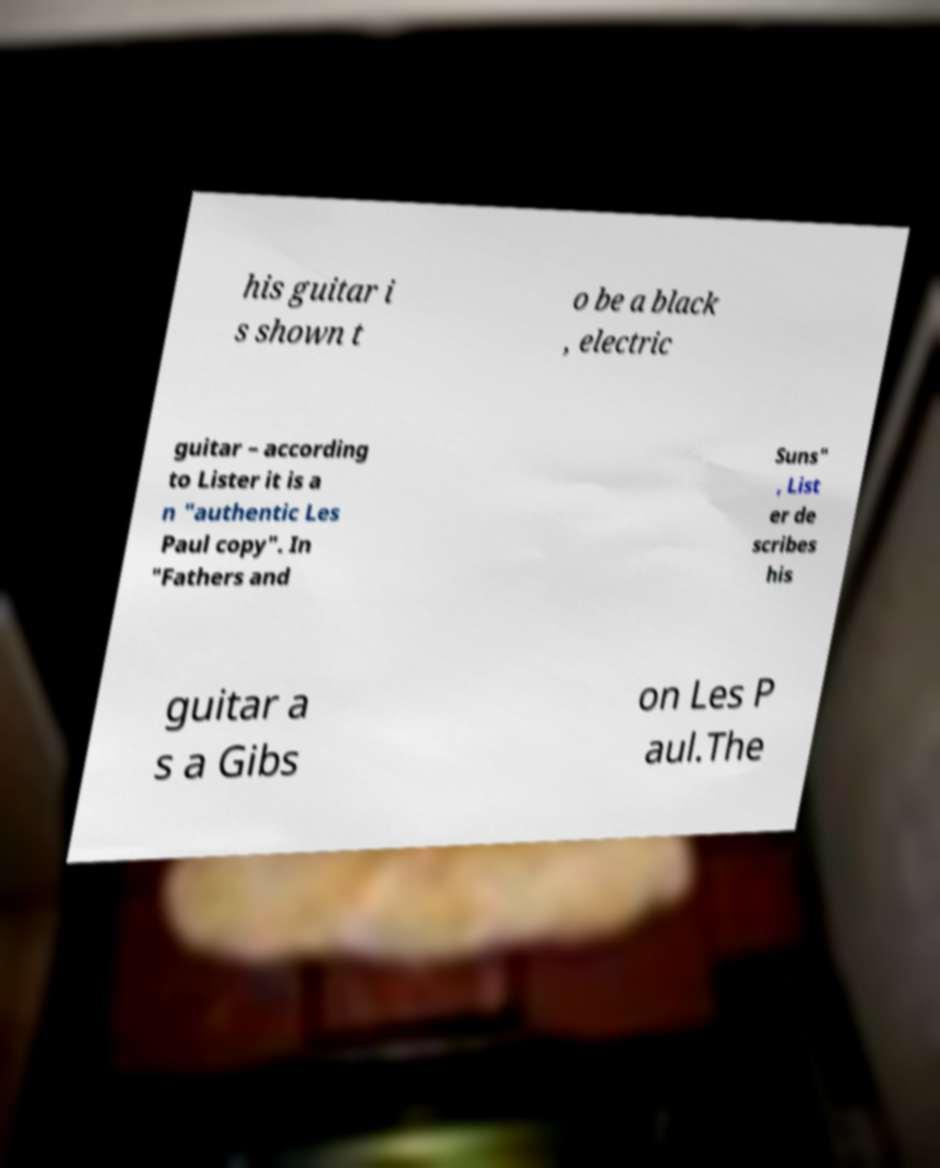Could you assist in decoding the text presented in this image and type it out clearly? his guitar i s shown t o be a black , electric guitar – according to Lister it is a n "authentic Les Paul copy". In "Fathers and Suns" , List er de scribes his guitar a s a Gibs on Les P aul.The 